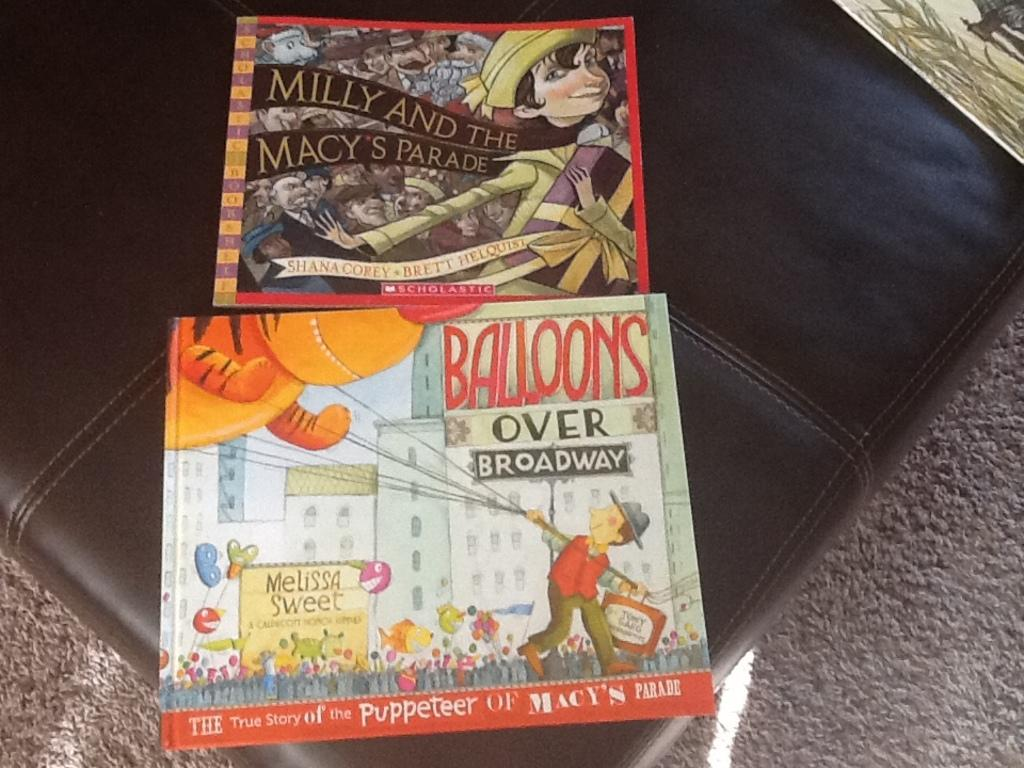Provide a one-sentence caption for the provided image. Milly and the Macy's Parade" was above "Balllons over Broadway. 